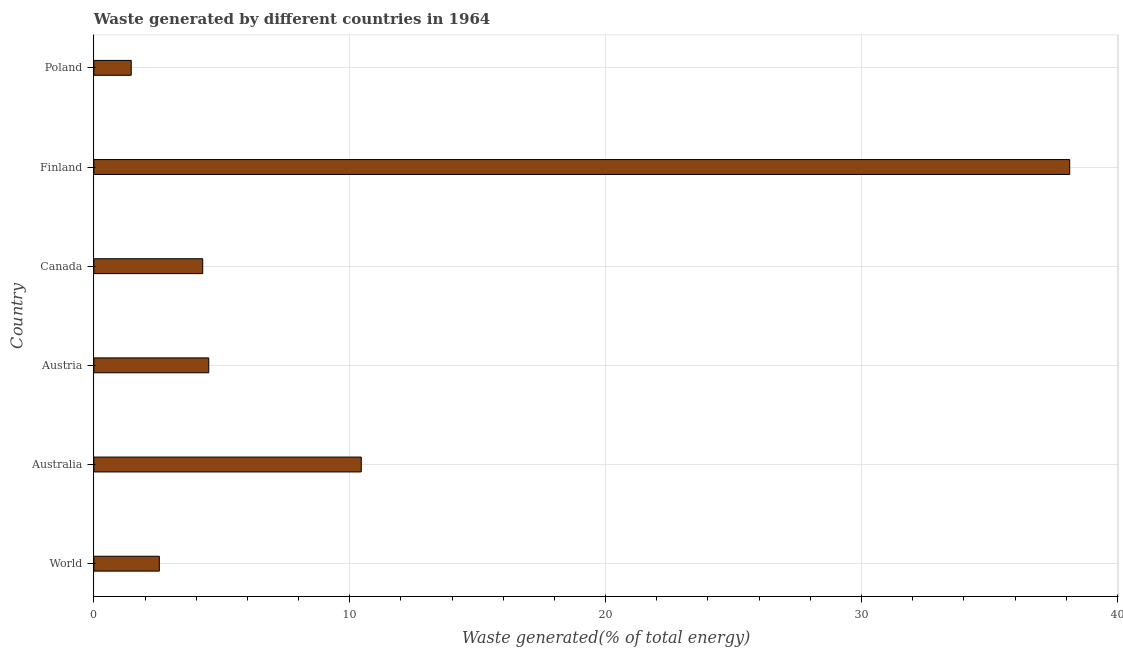Does the graph contain any zero values?
Your answer should be very brief. No. What is the title of the graph?
Your answer should be very brief. Waste generated by different countries in 1964. What is the label or title of the X-axis?
Your answer should be very brief. Waste generated(% of total energy). What is the label or title of the Y-axis?
Your answer should be compact. Country. What is the amount of waste generated in World?
Ensure brevity in your answer.  2.56. Across all countries, what is the maximum amount of waste generated?
Offer a terse response. 38.14. Across all countries, what is the minimum amount of waste generated?
Offer a very short reply. 1.46. In which country was the amount of waste generated maximum?
Make the answer very short. Finland. In which country was the amount of waste generated minimum?
Offer a terse response. Poland. What is the sum of the amount of waste generated?
Provide a succinct answer. 61.36. What is the difference between the amount of waste generated in Australia and Austria?
Your answer should be very brief. 5.96. What is the average amount of waste generated per country?
Keep it short and to the point. 10.23. What is the median amount of waste generated?
Offer a terse response. 4.37. In how many countries, is the amount of waste generated greater than 22 %?
Ensure brevity in your answer.  1. What is the ratio of the amount of waste generated in Finland to that in World?
Give a very brief answer. 14.89. Is the amount of waste generated in Poland less than that in World?
Give a very brief answer. Yes. Is the difference between the amount of waste generated in Australia and World greater than the difference between any two countries?
Your answer should be compact. No. What is the difference between the highest and the second highest amount of waste generated?
Ensure brevity in your answer.  27.68. Is the sum of the amount of waste generated in Finland and Poland greater than the maximum amount of waste generated across all countries?
Your response must be concise. Yes. What is the difference between the highest and the lowest amount of waste generated?
Offer a very short reply. 36.67. How many bars are there?
Provide a succinct answer. 6. Are all the bars in the graph horizontal?
Your response must be concise. Yes. What is the difference between two consecutive major ticks on the X-axis?
Your response must be concise. 10. Are the values on the major ticks of X-axis written in scientific E-notation?
Ensure brevity in your answer.  No. What is the Waste generated(% of total energy) of World?
Your answer should be very brief. 2.56. What is the Waste generated(% of total energy) in Australia?
Give a very brief answer. 10.45. What is the Waste generated(% of total energy) in Austria?
Offer a very short reply. 4.49. What is the Waste generated(% of total energy) of Canada?
Your answer should be very brief. 4.26. What is the Waste generated(% of total energy) of Finland?
Provide a short and direct response. 38.14. What is the Waste generated(% of total energy) in Poland?
Give a very brief answer. 1.46. What is the difference between the Waste generated(% of total energy) in World and Australia?
Offer a terse response. -7.89. What is the difference between the Waste generated(% of total energy) in World and Austria?
Your response must be concise. -1.93. What is the difference between the Waste generated(% of total energy) in World and Canada?
Keep it short and to the point. -1.7. What is the difference between the Waste generated(% of total energy) in World and Finland?
Provide a succinct answer. -35.58. What is the difference between the Waste generated(% of total energy) in World and Poland?
Provide a succinct answer. 1.1. What is the difference between the Waste generated(% of total energy) in Australia and Austria?
Keep it short and to the point. 5.96. What is the difference between the Waste generated(% of total energy) in Australia and Canada?
Offer a terse response. 6.2. What is the difference between the Waste generated(% of total energy) in Australia and Finland?
Offer a terse response. -27.68. What is the difference between the Waste generated(% of total energy) in Australia and Poland?
Provide a short and direct response. 8.99. What is the difference between the Waste generated(% of total energy) in Austria and Canada?
Provide a succinct answer. 0.24. What is the difference between the Waste generated(% of total energy) in Austria and Finland?
Offer a terse response. -33.64. What is the difference between the Waste generated(% of total energy) in Austria and Poland?
Offer a terse response. 3.03. What is the difference between the Waste generated(% of total energy) in Canada and Finland?
Make the answer very short. -33.88. What is the difference between the Waste generated(% of total energy) in Canada and Poland?
Make the answer very short. 2.79. What is the difference between the Waste generated(% of total energy) in Finland and Poland?
Offer a terse response. 36.67. What is the ratio of the Waste generated(% of total energy) in World to that in Australia?
Your response must be concise. 0.24. What is the ratio of the Waste generated(% of total energy) in World to that in Austria?
Your response must be concise. 0.57. What is the ratio of the Waste generated(% of total energy) in World to that in Canada?
Your response must be concise. 0.6. What is the ratio of the Waste generated(% of total energy) in World to that in Finland?
Ensure brevity in your answer.  0.07. What is the ratio of the Waste generated(% of total energy) in World to that in Poland?
Offer a terse response. 1.75. What is the ratio of the Waste generated(% of total energy) in Australia to that in Austria?
Ensure brevity in your answer.  2.33. What is the ratio of the Waste generated(% of total energy) in Australia to that in Canada?
Give a very brief answer. 2.46. What is the ratio of the Waste generated(% of total energy) in Australia to that in Finland?
Your response must be concise. 0.27. What is the ratio of the Waste generated(% of total energy) in Australia to that in Poland?
Provide a short and direct response. 7.15. What is the ratio of the Waste generated(% of total energy) in Austria to that in Canada?
Make the answer very short. 1.05. What is the ratio of the Waste generated(% of total energy) in Austria to that in Finland?
Ensure brevity in your answer.  0.12. What is the ratio of the Waste generated(% of total energy) in Austria to that in Poland?
Ensure brevity in your answer.  3.07. What is the ratio of the Waste generated(% of total energy) in Canada to that in Finland?
Your response must be concise. 0.11. What is the ratio of the Waste generated(% of total energy) in Canada to that in Poland?
Give a very brief answer. 2.91. What is the ratio of the Waste generated(% of total energy) in Finland to that in Poland?
Give a very brief answer. 26.09. 